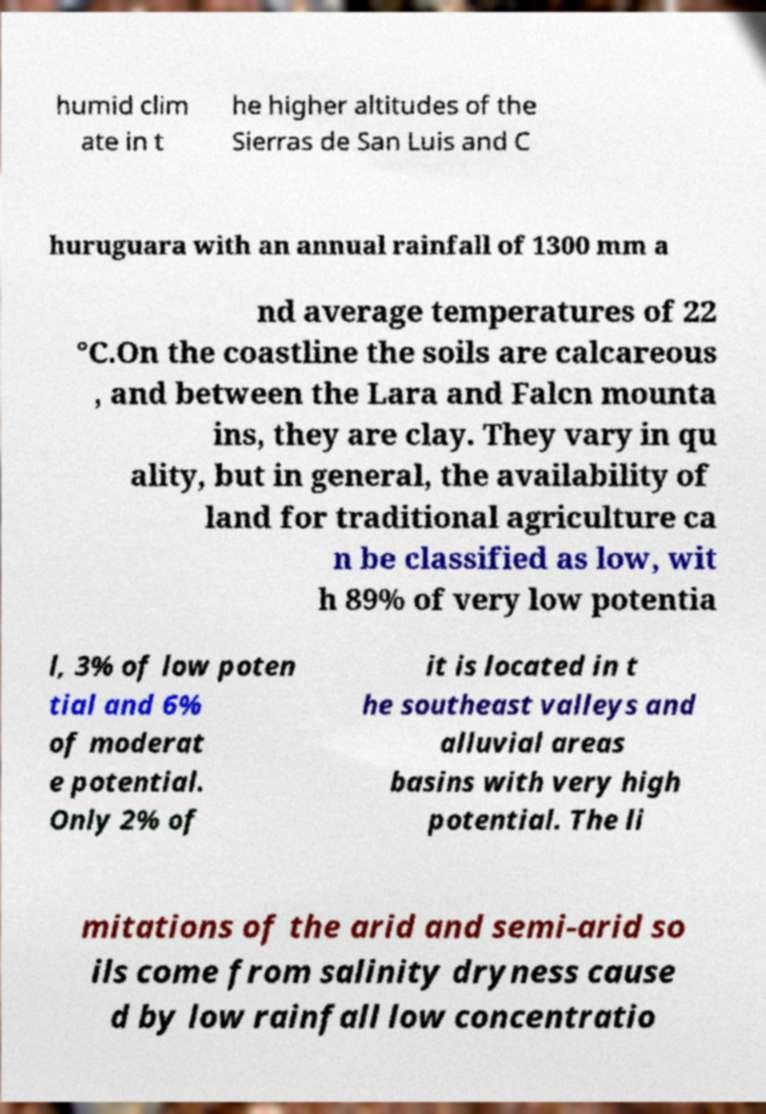I need the written content from this picture converted into text. Can you do that? humid clim ate in t he higher altitudes of the Sierras de San Luis and C huruguara with an annual rainfall of 1300 mm a nd average temperatures of 22 °C.On the coastline the soils are calcareous , and between the Lara and Falcn mounta ins, they are clay. They vary in qu ality, but in general, the availability of land for traditional agriculture ca n be classified as low, wit h 89% of very low potentia l, 3% of low poten tial and 6% of moderat e potential. Only 2% of it is located in t he southeast valleys and alluvial areas basins with very high potential. The li mitations of the arid and semi-arid so ils come from salinity dryness cause d by low rainfall low concentratio 